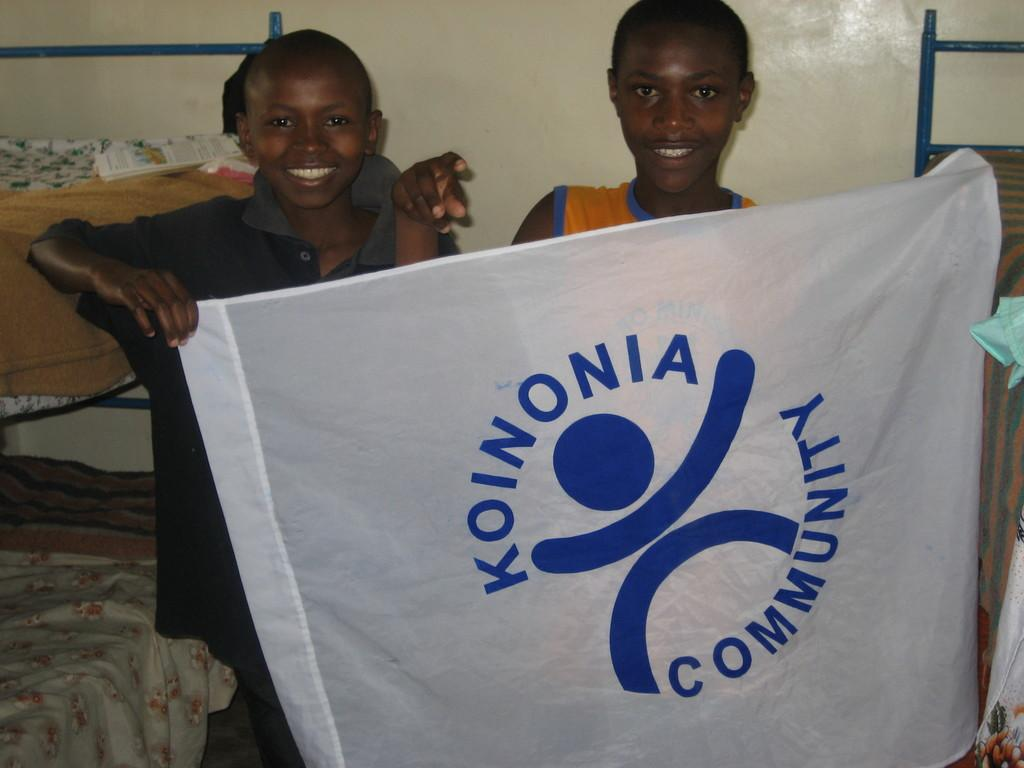How many children are in the image? There are two children in the image. What are the children holding in the image? The children are holding a banner in the image. What can be seen in the background of the image? In the background of the image, there are beds, paper, clothes, and a wall. What type of whip can be seen in the image? There is no whip present in the image. How many oranges are visible on the wall in the image? There are no oranges visible in the image. 